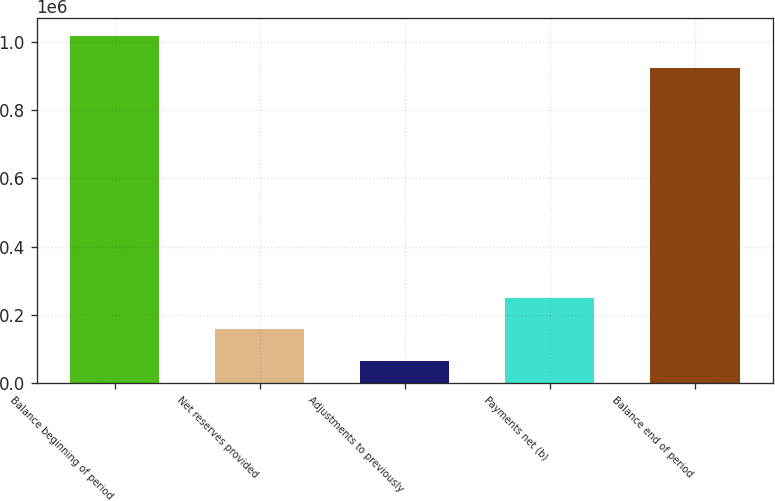<chart> <loc_0><loc_0><loc_500><loc_500><bar_chart><fcel>Balance beginning of period<fcel>Net reserves provided<fcel>Adjustments to previously<fcel>Payments net (b)<fcel>Balance end of period<nl><fcel>1.01765e+06<fcel>157867<fcel>64775<fcel>250958<fcel>924563<nl></chart> 